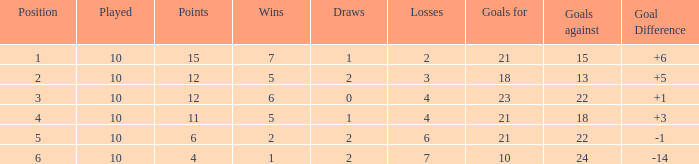Can you disclose the complete sum of wins having draws more than 0, and the points equivalent to 11? 1.0. 